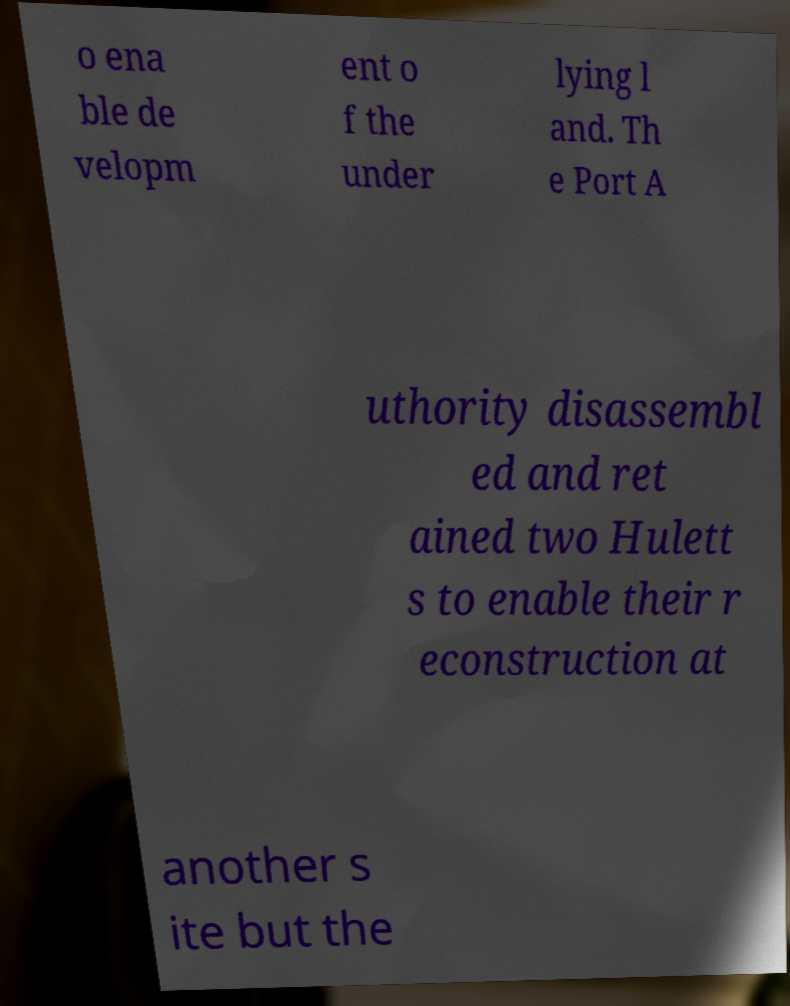Please identify and transcribe the text found in this image. o ena ble de velopm ent o f the under lying l and. Th e Port A uthority disassembl ed and ret ained two Hulett s to enable their r econstruction at another s ite but the 